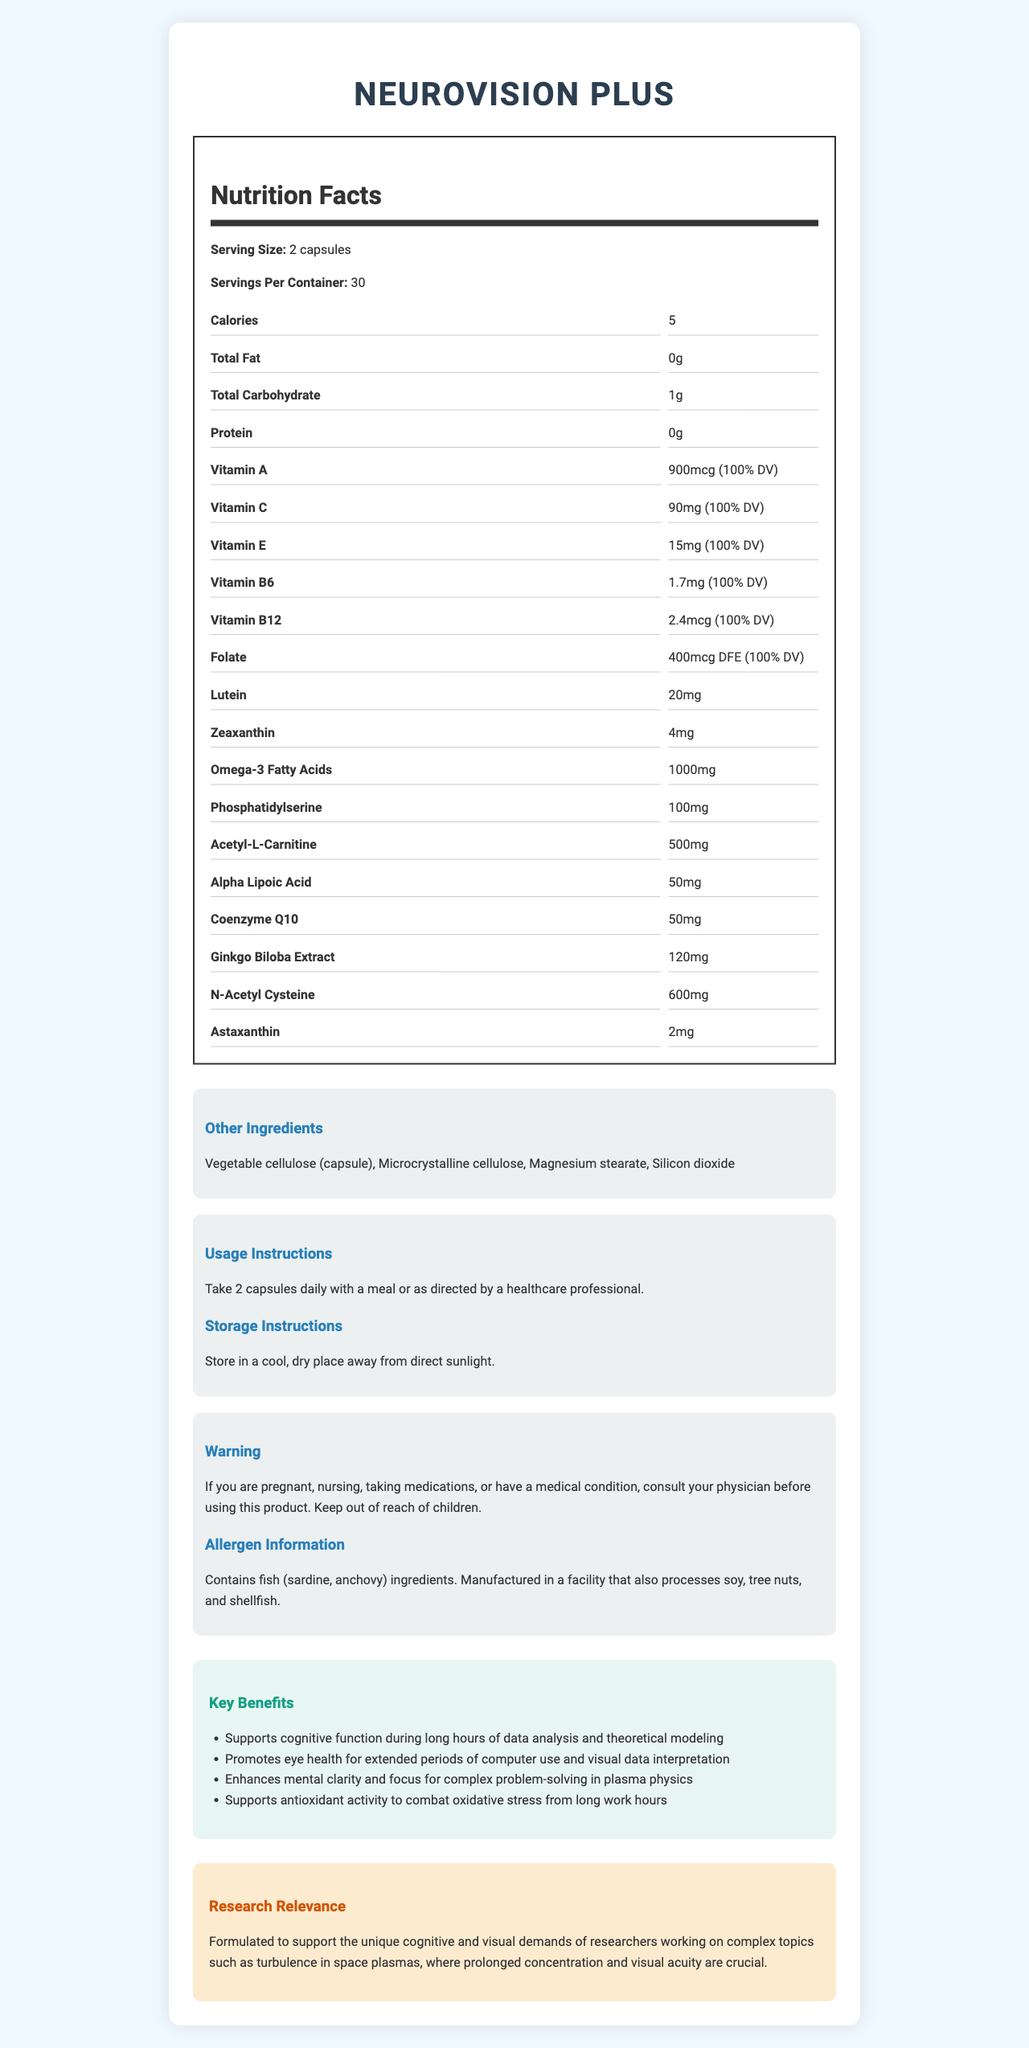what is the serving size of NeuroVision Plus? The serving size is clearly stated as "2 capsules" in the document.
Answer: 2 capsules how many calories are in one serving? The document mentions that each serving contains 5 calories.
Answer: 5 calories what percentage of the daily value of Vitamin A does NeuroVision Plus provide per serving? The document indicates that NeuroVision Plus provides 900 mcg of Vitamin A, which is 100% of the daily value.
Answer: 100% DV list the vitamins included in NeuroVision Plus and their amounts per serving. The document specifies the amounts of each vitamin alongside their names.
Answer: Vitamin A: 900mcg, Vitamin C: 90mg, Vitamin E: 15mg, Vitamin B6: 1.7mg, Vitamin B12: 2.4mcg, Folate: 400mcg DFE what is the main benefit of Lutein in NeuroVision Plus? Lutein is known for its benefits to eye health, which is consistent with the product's focus on promoting eye health for extended computer use and visual data interpretation.
Answer: Promotes eye health which of the following ingredients are not included in NeuroVision Plus? A. Omega-3 Fatty Acids B. Lutein C. Magnesium D. Coenzyme Q10 Magnesium is not listed as one of the ingredients in the document.
Answer: C. Magnesium how should NeuroVision Plus be stored? The storage instructions provided in the document state to store the supplement in a cool, dry place away from direct sunlight.
Answer: In a cool, dry place, away from direct sunlight does NeuroVision Plus contain any allergens? The allergen information states that the product contains fish (sardine, anchovy) ingredients and is manufactured in a facility that processes soy, tree nuts, and shellfish.
Answer: Yes are there any warnings associated with taking NeuroVision Plus? The document includes a warning advising to consult a physician if you are pregnant, nursing, taking medications, or have a medical condition, and to keep the product out of reach of children.
Answer: Yes what is the total carbohydrate content per serving? The nutrition facts list the total carbohydrate content per serving as 1 gram.
Answer: 1g which ingredient listed has the highest amount in NeuroVision Plus? The item with the highest quantity per serving listed in the document is Omega-3 Fatty Acids, with 1000mg.
Answer: Omega-3 Fatty Acids, 1000mg what are the key benefits of NeuroVision Plus for researchers? The document lists key benefits tailored for researchers, focusing on cognitive function, eye health, mental clarity, focus, and antioxidant activity.
Answer: Supports cognitive function, promotes eye health, enhances mental clarity and focus, supports antioxidant activity what visual and cognitive demands does NeuroVision Plus aim to support for plasma physicists? The product is formulated to meet the visual and cognitive demands that plasma physicists face, such as prolonged concentration and visual acuity during their analysis of space plasma turbulence.
Answer: Supports cognitive function during long hours of data analysis and theoretical modeling, promotes eye health for extended periods of computer use and visual data interpretation. is it possible to determine which medical conditions the product is intended to treat? The document does not specify any medical conditions but rather emphasizes support for cognitive and visual performance in general.
Answer: Not enough information summarize the information provided in the document. The document provides a detailed description of the NeuroVision Plus supplement, including its nutritional content, benefits for researchers, instructions for use, and relevant warnings and allergen information.
Answer: NeuroVision Plus is a vitamin supplement designed for researchers, particularly plasma physicists, to support cognitive function and eye health. Each serving consists of 2 capsules, with a total of 30 servings per container. The nutrition facts label lists various vitamins and ingredients, including Omega-3 Fatty Acids, Lutein, and others. The product offers specific benefits such as cognitive support and eye health promotion. The document also includes usage, storage instructions, and allergen information, and notes that the product contains fish ingredients. 